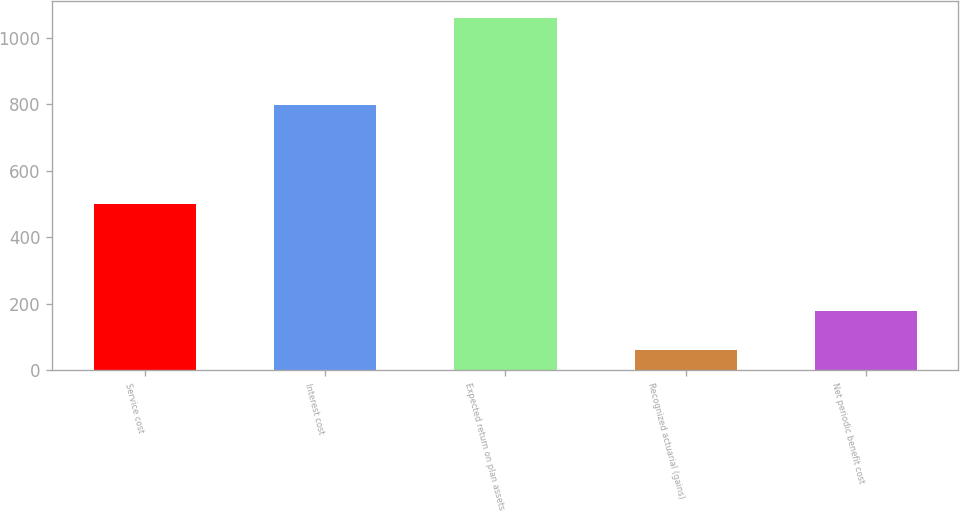Convert chart to OTSL. <chart><loc_0><loc_0><loc_500><loc_500><bar_chart><fcel>Service cost<fcel>Interest cost<fcel>Expected return on plan assets<fcel>Recognized actuarial (gains)<fcel>Net periodic benefit cost<nl><fcel>499<fcel>798<fcel>1059<fcel>61<fcel>177<nl></chart> 